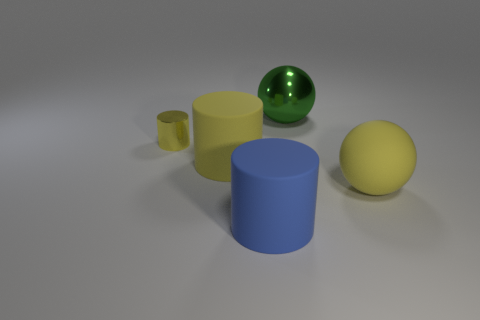Add 3 brown balls. How many objects exist? 8 Subtract all blue spheres. Subtract all blue cylinders. How many spheres are left? 2 Subtract all cylinders. How many objects are left? 2 Subtract 0 blue cubes. How many objects are left? 5 Subtract all spheres. Subtract all large yellow cylinders. How many objects are left? 2 Add 4 blue rubber things. How many blue rubber things are left? 5 Add 5 tiny cyan rubber blocks. How many tiny cyan rubber blocks exist? 5 